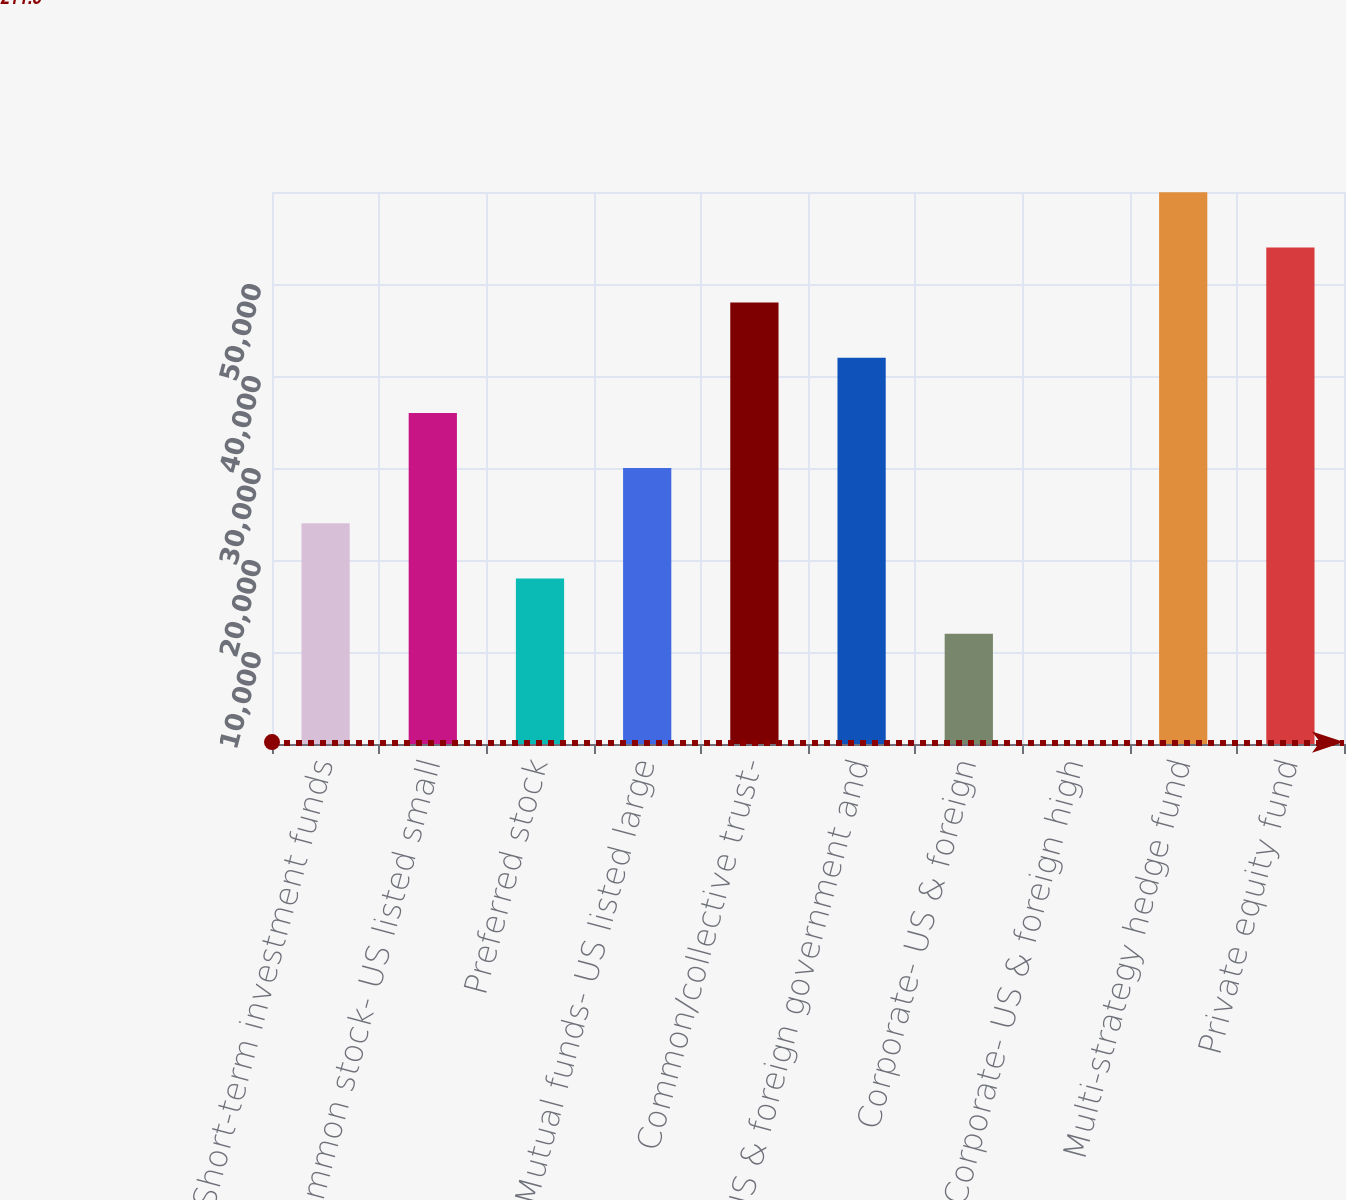Convert chart to OTSL. <chart><loc_0><loc_0><loc_500><loc_500><bar_chart><fcel>Short-term investment funds<fcel>Common stock- US listed small<fcel>Preferred stock<fcel>Mutual funds- US listed large<fcel>Common/collective trust-<fcel>US & foreign government and<fcel>Corporate- US & foreign<fcel>Corporate- US & foreign high<fcel>Multi-strategy hedge fund<fcel>Private equity fund<nl><fcel>23991.1<fcel>35986.4<fcel>17993.5<fcel>29988.8<fcel>47981.7<fcel>41984.1<fcel>11995.8<fcel>0.5<fcel>59977<fcel>53979.3<nl></chart> 